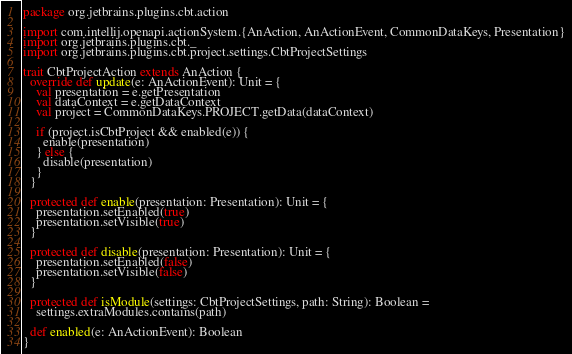Convert code to text. <code><loc_0><loc_0><loc_500><loc_500><_Scala_>package org.jetbrains.plugins.cbt.action

import com.intellij.openapi.actionSystem.{AnAction, AnActionEvent, CommonDataKeys, Presentation}
import org.jetbrains.plugins.cbt._
import org.jetbrains.plugins.cbt.project.settings.CbtProjectSettings

trait CbtProjectAction extends AnAction {
  override def update(e: AnActionEvent): Unit = {
    val presentation = e.getPresentation
    val dataContext = e.getDataContext
    val project = CommonDataKeys.PROJECT.getData(dataContext)

    if (project.isCbtProject && enabled(e)) {
      enable(presentation)
    } else {
      disable(presentation)
    }
  }

  protected def enable(presentation: Presentation): Unit = {
    presentation.setEnabled(true)
    presentation.setVisible(true)
  }

  protected def disable(presentation: Presentation): Unit = {
    presentation.setEnabled(false)
    presentation.setVisible(false)
  }

  protected def isModule(settings: CbtProjectSettings, path: String): Boolean =
    settings.extraModules.contains(path)

  def enabled(e: AnActionEvent): Boolean
}
</code> 